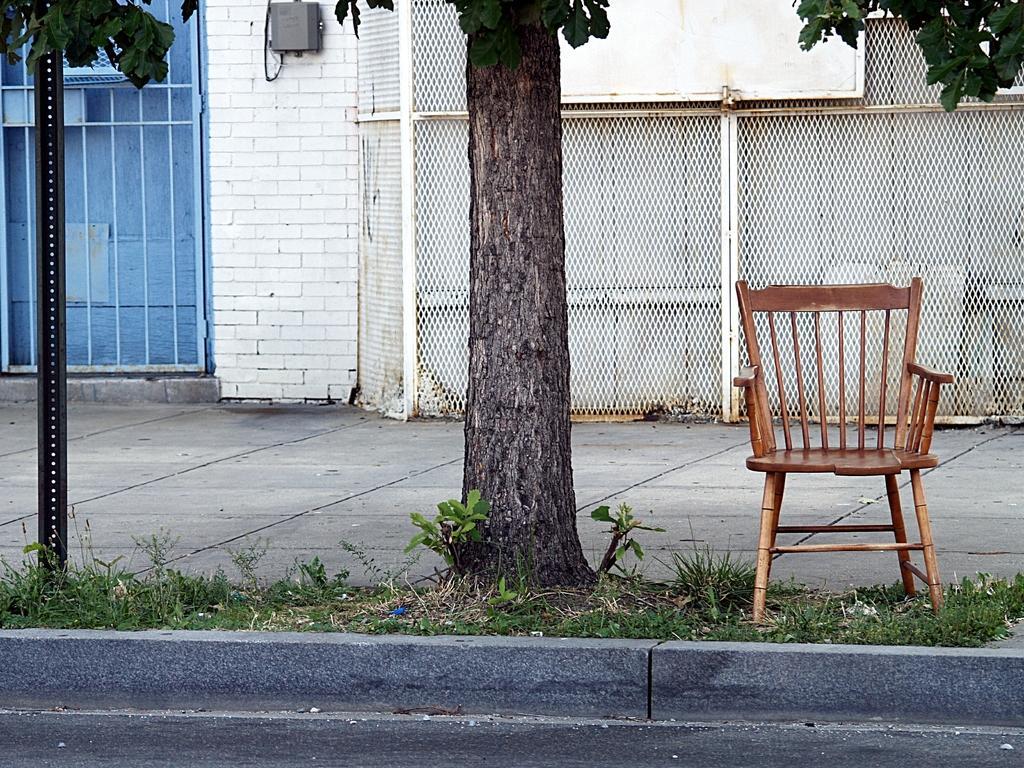Please provide a concise description of this image. In this image there is a chair on the land having plants and a tree. Left side there is a pole. Background there is a wall having a fence. Bottom of the image there is a road. 